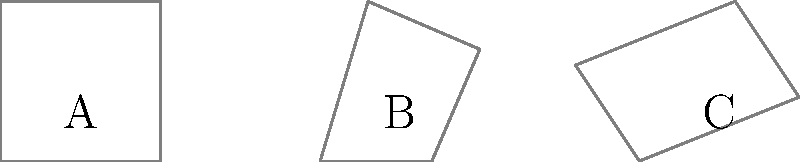As part of a spatial reasoning exercise for recovering alcoholics, you're presented with a 3D cube and three 2D shadows labeled A, B, and C. Which shadow accurately represents the projection of the cube when viewed from directly above? To solve this problem, we need to analyze the 3D cube and compare it to the given 2D shadows:

1. First, let's consider the properties of a cube viewed from directly above:
   - All edges parallel to the viewing direction will appear as points.
   - All edges perpendicular to the viewing direction will appear as lines.
   - The resulting shape will be a perfect square.

2. Now, let's examine each shadow:
   
   Shadow A:
   - This is a perfect square.
   - It matches what we expect to see when viewing a cube from directly above.

   Shadow B:
   - This is not a perfect square; it has two parallel sides that are longer than the other two.
   - This shape would result from viewing the cube at an angle, not directly from above.

   Shadow C:
   - This is an irregular quadrilateral.
   - It does not represent a cube viewed from any single, static angle.

3. Based on this analysis, we can conclude that Shadow A is the correct representation of the cube when viewed from directly above.

This exercise helps reinforce spatial reasoning skills, which can be beneficial for recovering alcoholics in understanding and visualizing complex problems from different perspectives.
Answer: A 